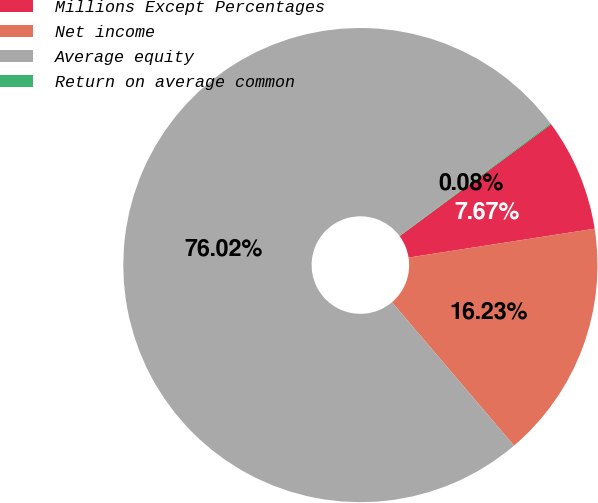Convert chart to OTSL. <chart><loc_0><loc_0><loc_500><loc_500><pie_chart><fcel>Millions Except Percentages<fcel>Net income<fcel>Average equity<fcel>Return on average common<nl><fcel>7.67%<fcel>16.23%<fcel>76.02%<fcel>0.08%<nl></chart> 